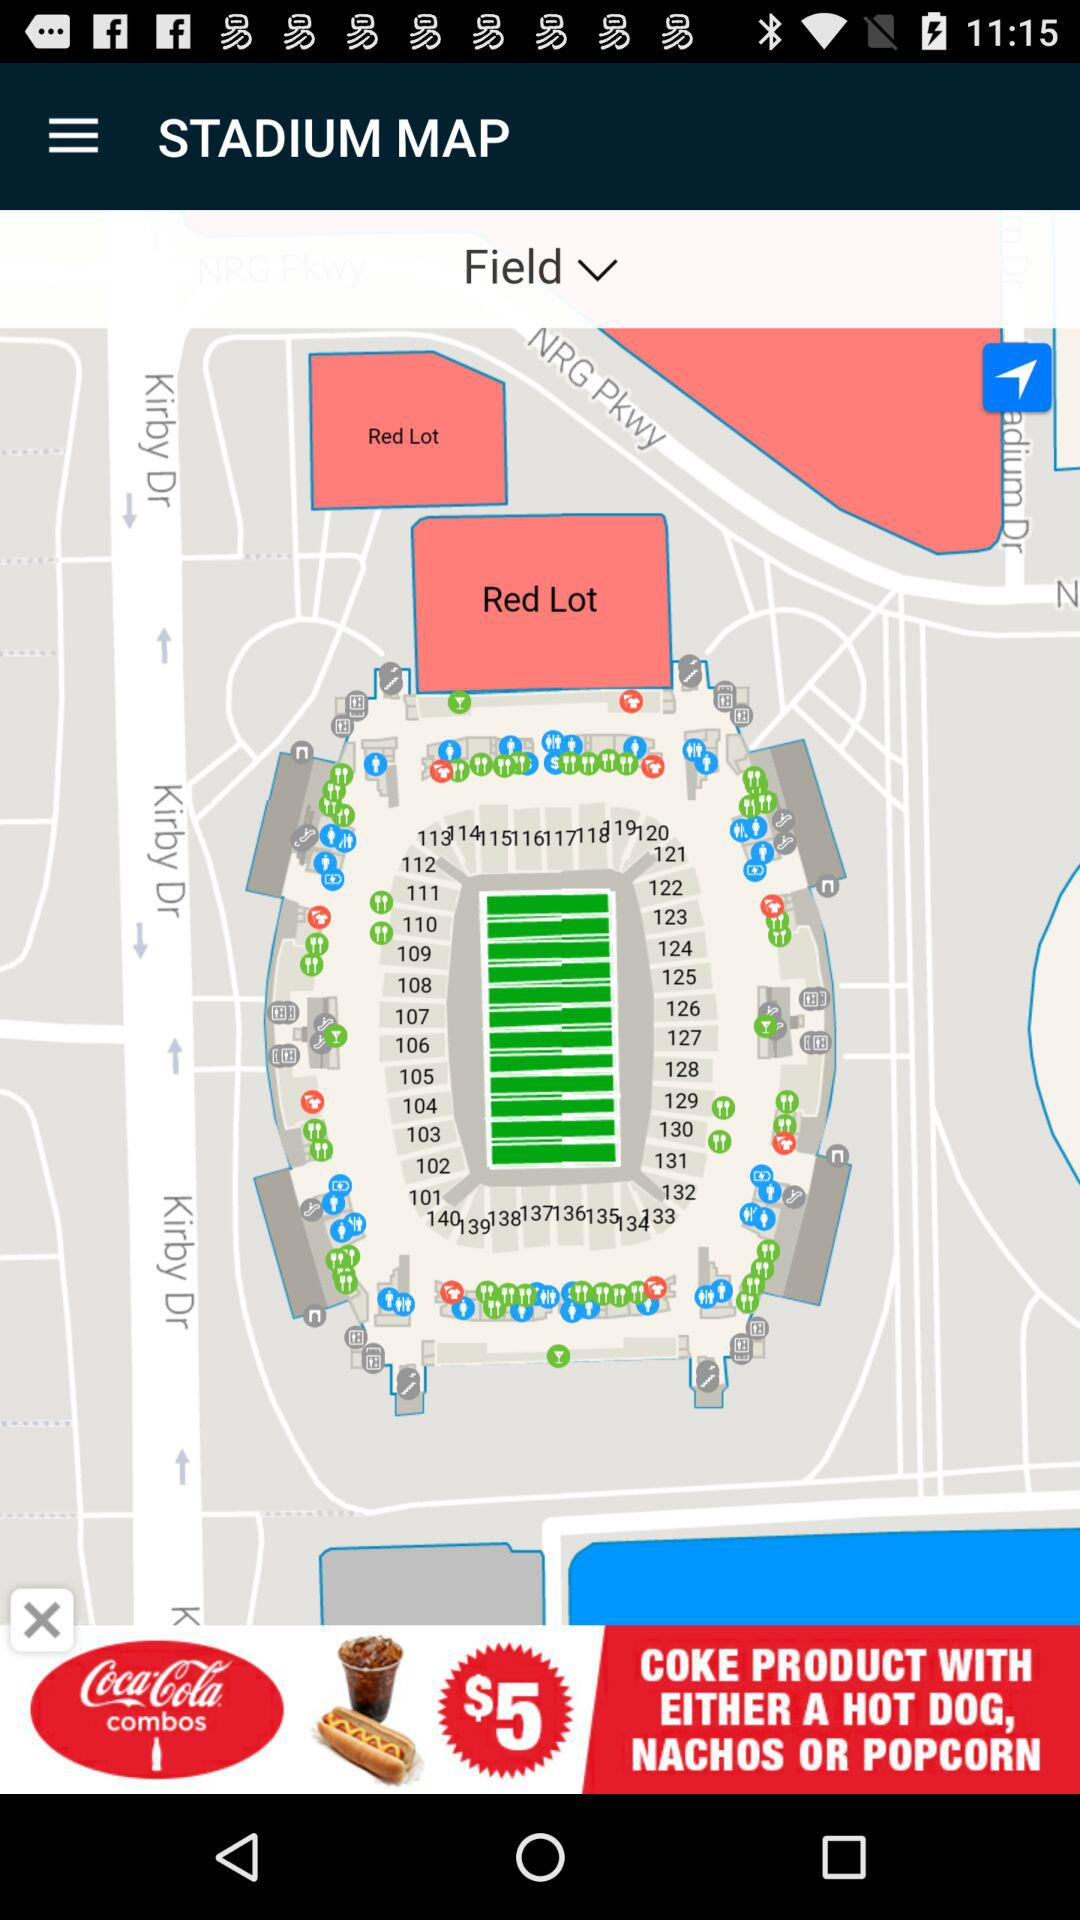How much is the combo with a hot dog?
Answer the question using a single word or phrase. $5 